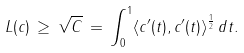<formula> <loc_0><loc_0><loc_500><loc_500>L ( c ) \, \geq \, \sqrt { C } \, = \, \int _ { 0 } ^ { 1 } \langle c ^ { \prime } ( t ) , c ^ { \prime } ( t ) \rangle ^ { \frac { 1 } { 2 } } \, d t .</formula> 